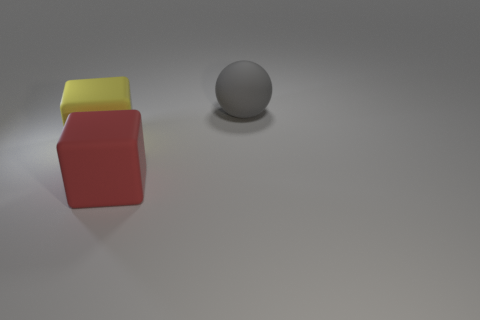There is a matte object behind the rubber cube that is to the left of the big red object; what size is it?
Offer a terse response. Large. There is a big cube that is to the left of the large red matte block; what is its color?
Keep it short and to the point. Yellow. Are there any large yellow rubber objects that have the same shape as the large red object?
Your answer should be compact. Yes. Are there fewer big rubber objects behind the large gray matte thing than red matte blocks that are to the right of the yellow thing?
Your answer should be very brief. Yes. What color is the sphere?
Provide a short and direct response. Gray. There is a cube that is behind the big red cube; is there a big block that is in front of it?
Keep it short and to the point. Yes. How many other yellow rubber cubes are the same size as the yellow matte cube?
Make the answer very short. 0. There is a thing that is right of the large thing in front of the big yellow rubber block; how many large spheres are on the right side of it?
Ensure brevity in your answer.  0. How many big objects are both to the right of the big yellow cube and behind the red thing?
Offer a terse response. 1. Are there any other things that are the same color as the matte sphere?
Your response must be concise. No. 